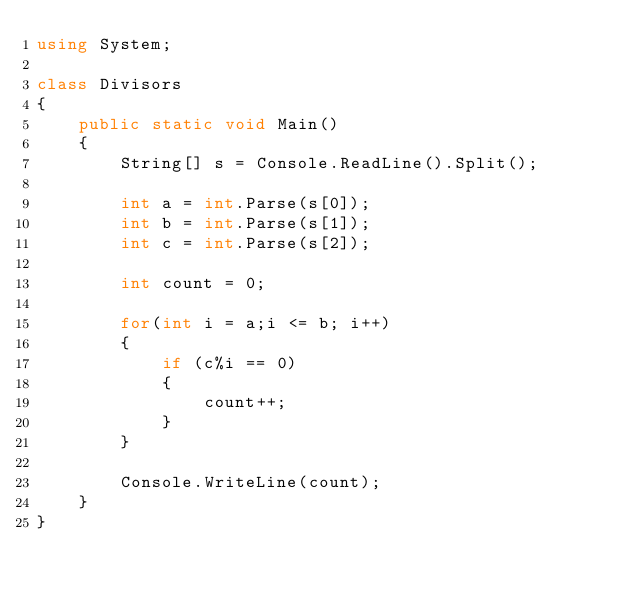<code> <loc_0><loc_0><loc_500><loc_500><_C#_>using System;

class Divisors
{
    public static void Main()
    {
        String[] s = Console.ReadLine().Split();

        int a = int.Parse(s[0]);
        int b = int.Parse(s[1]);
        int c = int.Parse(s[2]);

        int count = 0;

        for(int i = a;i <= b; i++)
        {
            if (c%i == 0)
            {
                count++;
            }
        }

        Console.WriteLine(count);
    }
}
</code> 